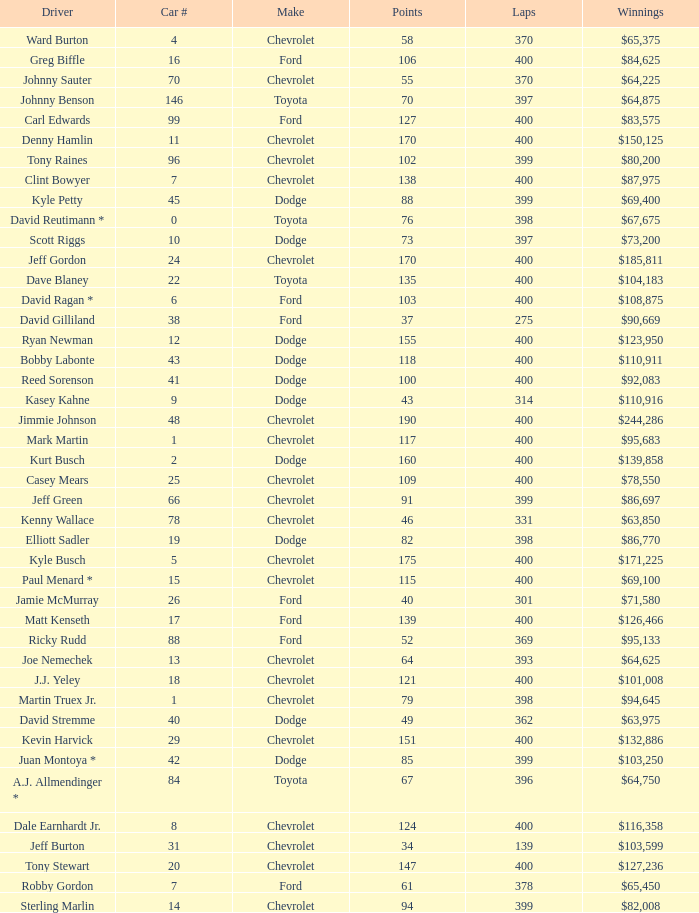What is the car number that has less than 369 laps for a Dodge with more than 49 points? None. 